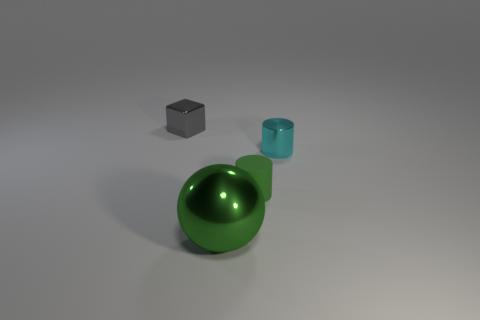Are there any small cylinders that have the same color as the large object?
Provide a succinct answer. Yes. There is a metallic thing that is the same color as the rubber object; what is its size?
Ensure brevity in your answer.  Large. What is the material of the small cylinder left of the small shiny object that is on the right side of the large green sphere?
Ensure brevity in your answer.  Rubber. How many objects are either big blue metallic things or shiny objects that are behind the small rubber thing?
Keep it short and to the point. 2. The green ball that is the same material as the tiny gray thing is what size?
Keep it short and to the point. Large. How many gray things are tiny metal cubes or tiny metal cylinders?
Provide a short and direct response. 1. There is a shiny object that is the same color as the tiny rubber object; what shape is it?
Your answer should be very brief. Sphere. Is there anything else that has the same material as the green cylinder?
Offer a terse response. No. Is the shape of the tiny shiny thing that is in front of the gray metal thing the same as the thing on the left side of the green metal thing?
Your answer should be compact. No. What number of big red cylinders are there?
Keep it short and to the point. 0. 